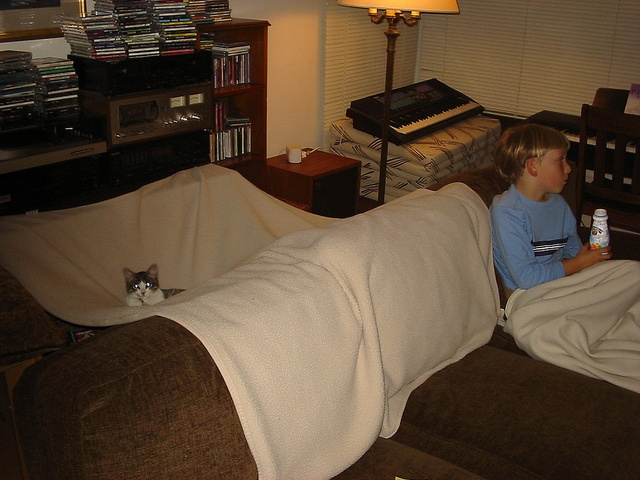Describe the objects in this image and their specific colors. I can see couch in black, tan, and gray tones, people in black, gray, and maroon tones, chair in black, gray, and maroon tones, book in black and gray tones, and cat in black, maroon, and gray tones in this image. 